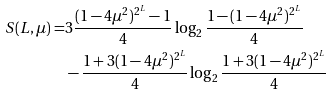<formula> <loc_0><loc_0><loc_500><loc_500>S ( L , \mu ) = & 3 \frac { ( 1 - 4 \mu ^ { 2 } ) ^ { 2 ^ { L } } - 1 } { 4 } \log _ { 2 } { \frac { 1 - ( 1 - 4 \mu ^ { 2 } ) ^ { 2 ^ { L } } } { 4 } } \\ & - \frac { 1 + 3 ( 1 - 4 \mu ^ { 2 } ) ^ { 2 ^ { L } } } { 4 } \log _ { 2 } { \frac { 1 + 3 ( 1 - 4 \mu ^ { 2 } ) ^ { 2 ^ { L } } } { 4 } }</formula> 